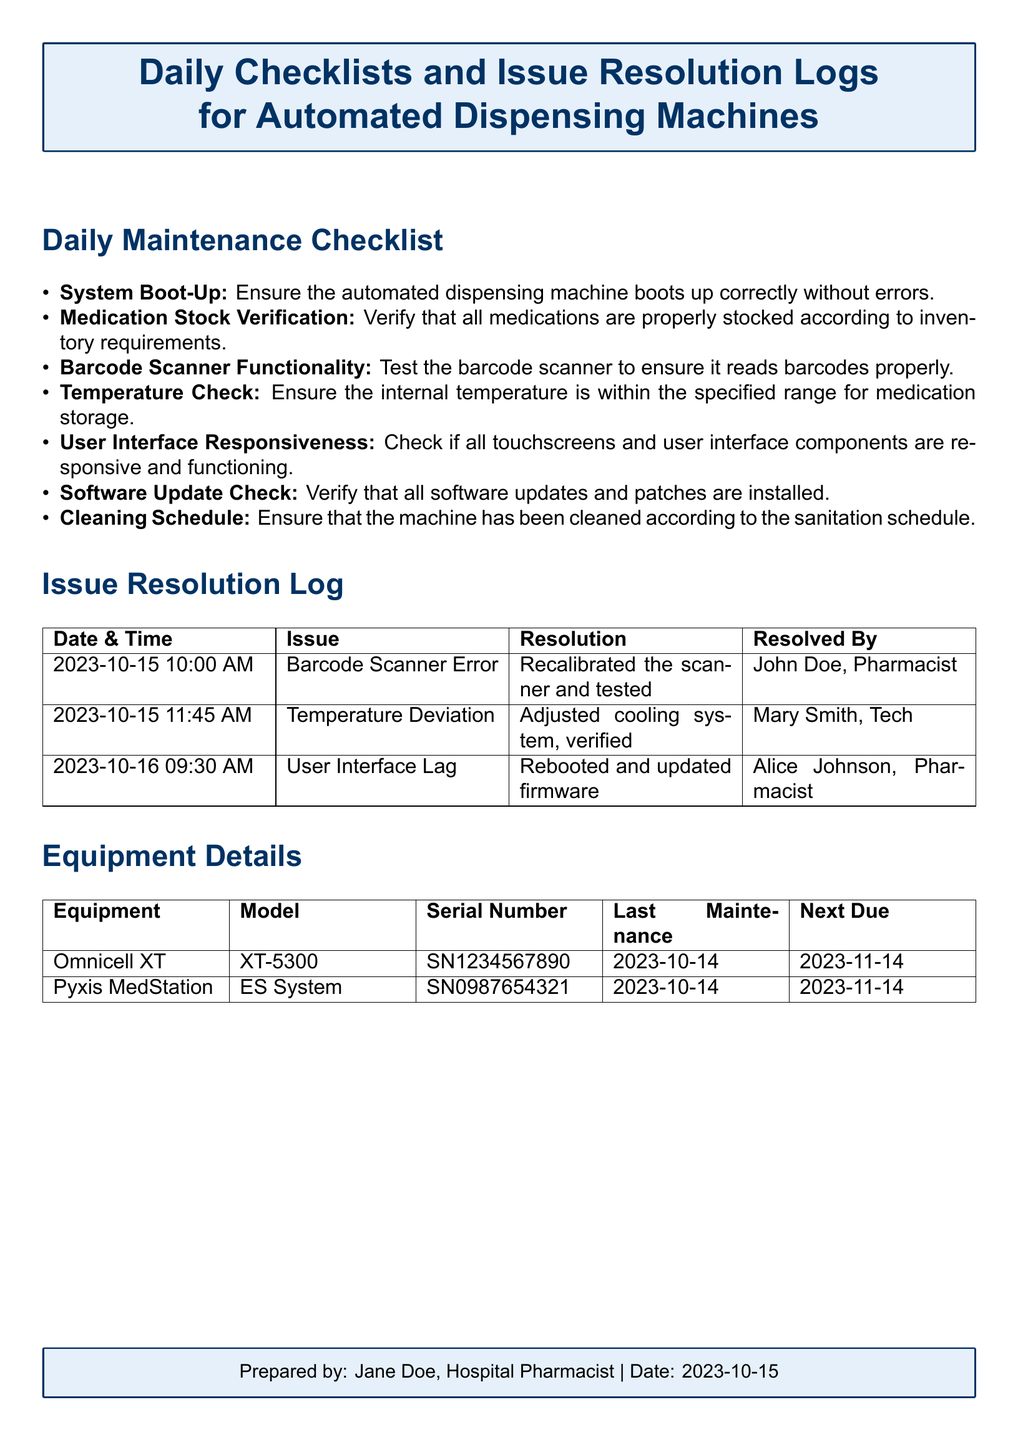what is the first item on the Daily Maintenance Checklist? The first item is the system boot-up verification for the automated dispensing machine.
Answer: System Boot-Up what issue occurred on 2023-10-15 at 10:00 AM? The issue was related to the barcode scanner error that required recalibration.
Answer: Barcode Scanner Error who resolved the User Interface Lag issue? The User Interface Lag issue was resolved by Alice Johnson.
Answer: Alice Johnson when is the next due maintenance for the Omnicell XT? The next due maintenance date for the Omnicell XT is listed in the Equipment Details section.
Answer: 2023-11-14 how many items are in the Daily Maintenance Checklist? The document specifies a list of maintenance tasks that includes several items.
Answer: 7 what resolution was applied for the Temperature Deviation issue? The resolution involved adjusting the cooling system and verifying its function.
Answer: Adjusted cooling system, verified what is the model of the Pyxis MedStation? The model of the Pyxis MedStation is indicated in the Equipment Details section.
Answer: ES System which pharmacist prepared this document? The document indicates who prepared it at the bottom.
Answer: Jane Doe 